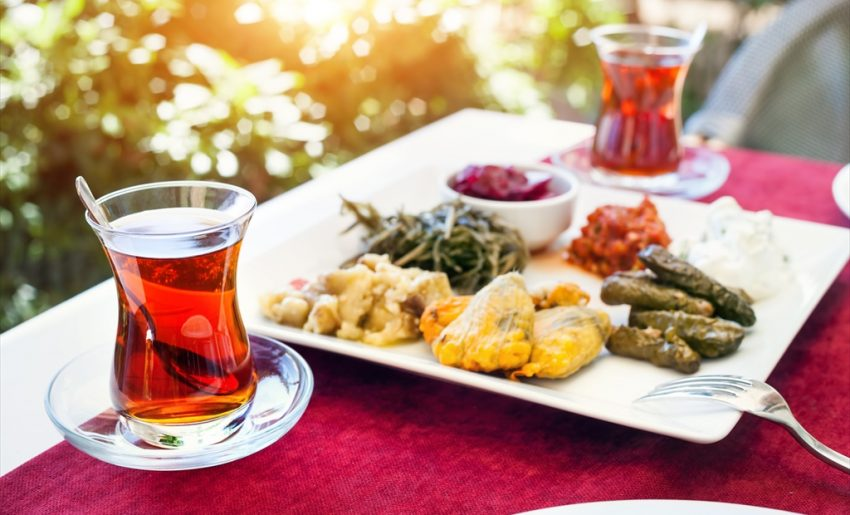Considering the variety of dishes on the plate, what can be inferred about the cultural or regional origin of the meal presented? The plate presented is a quintessential representation of Mediterranean or Middle Eastern cuisine, featuring classic dishes like stuffed grape leaves, commonly known as dolmas in the region. Additionally, the presence of a yogurt-based dip, likely tzatziki, and a salad possibly made with beets, aligns with the typical fare from this geographic area. The serving of strong black tea, seen in a clear glass which is a method popularly embraced in Turkey and its surroundings, further underscores these cultural culinary connections. Moreover, viewing the breadth of dishes, from dips to pickled vegetables, reiterates the gastronomic diversity prevalent in the Mediterranean and Middle Eastern regions, highlighting how shared ingredients and techniques traverse national boundaries but are localized per specific tastes. 